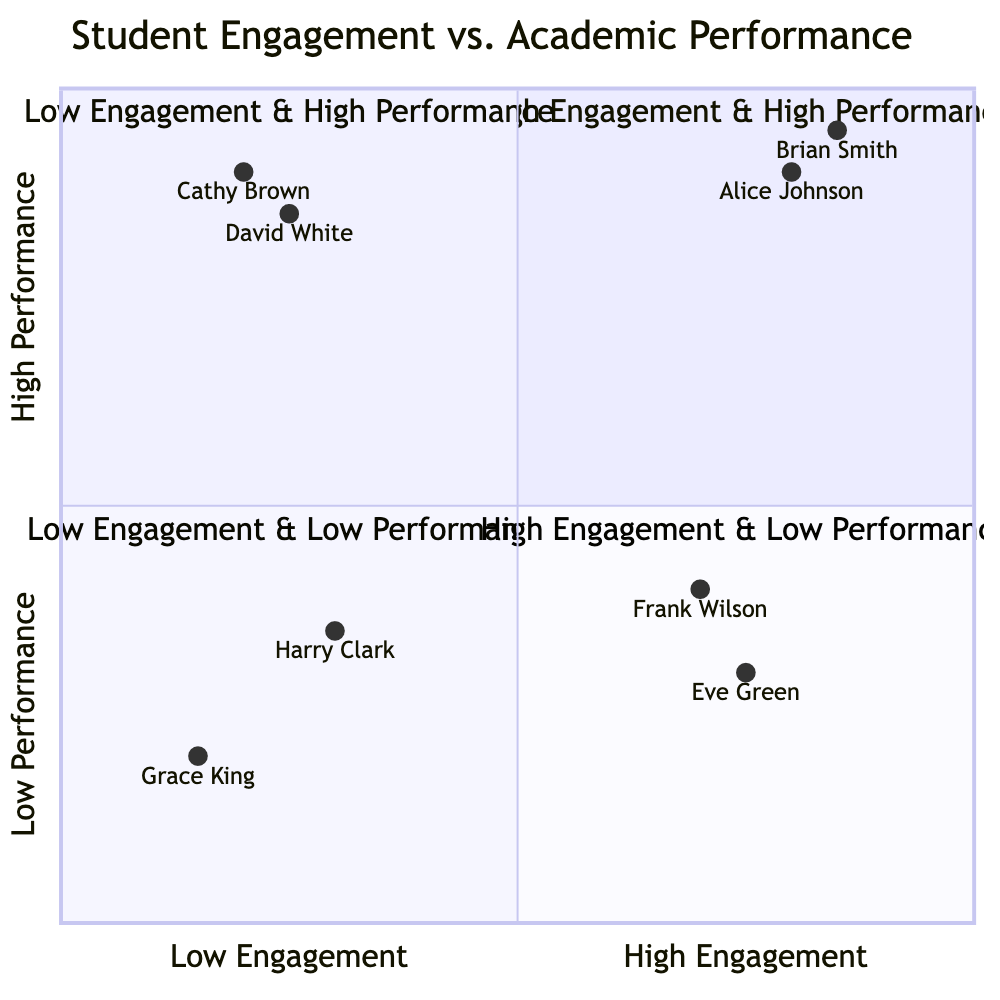What students are in the High Engagement & High Performance quadrant? The High Engagement & High Performance quadrant lists Alice Johnson and Brian Smith as examples.
Answer: Alice Johnson, Brian Smith Which student has the highest academic performance in the Low Engagement & High Performance quadrant? The highest academic performance in this quadrant is by Cathy Brown with an "A".
Answer: Cathy Brown How many students are in the Low Engagement & Low Performance quadrant? There are two students identified in the Low Engagement & Low Performance quadrant, Grace King and Harry Clark.
Answer: 2 What sport does Eve Green participate in? Eve Green is listed under the High Engagement & Low Performance quadrant and is involved in Tennis.
Answer: Tennis Which quadrant has students with both engagement levels and academic performance at their lowest? The quadrant that has the lowest levels of both engagement and academic performance is Low Engagement & Low Performance, containing students like Grace King and Harry Clark.
Answer: Low Engagement & Low Performance What is Brian Smith's engagement level? Brian Smith is noted in the High Engagement & High Performance quadrant, indicating a High engagement level.
Answer: High How does the academic performance of Frank Wilson compare to Eve Green? Frank Wilson has a higher academic performance (B-) compared to Eve Green (C), despite both being in the High Engagement & Low Performance quadrant.
Answer: Frank Wilson In the Low Engagement & High Performance quadrant, how many students are involved in sports? There is only one student involved in a sport, David White, who participates in Chess.
Answer: 1 What is the engagement level of Grace King? Grace King is noted as having a Low engagement level in the Low Engagement & Low Performance quadrant.
Answer: Low 